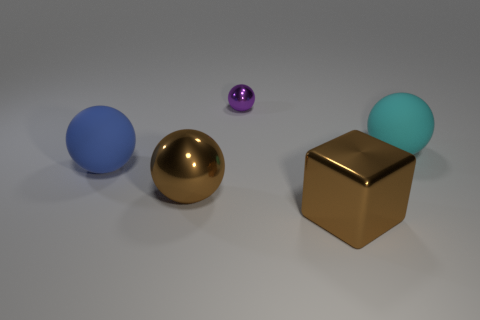How many other things are made of the same material as the cyan ball?
Your answer should be compact. 1. Is the material of the sphere that is in front of the large blue matte ball the same as the large cube?
Offer a terse response. Yes. What is the shape of the cyan object?
Offer a very short reply. Sphere. Are there more blue things that are right of the purple object than big brown matte cylinders?
Offer a terse response. No. Is there any other thing that is the same shape as the purple thing?
Offer a terse response. Yes. There is a big metallic thing that is the same shape as the small purple thing; what is its color?
Make the answer very short. Brown. There is a large brown object behind the metallic cube; what shape is it?
Your answer should be very brief. Sphere. There is a tiny purple shiny object; are there any cyan matte spheres to the left of it?
Your answer should be very brief. No. Are there any other things that have the same size as the purple object?
Your answer should be compact. No. There is a big sphere that is made of the same material as the tiny purple ball; what is its color?
Make the answer very short. Brown. 